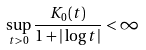Convert formula to latex. <formula><loc_0><loc_0><loc_500><loc_500>\sup _ { t > 0 } \frac { K _ { 0 } ( t ) } { 1 + | \log t | } < \infty</formula> 